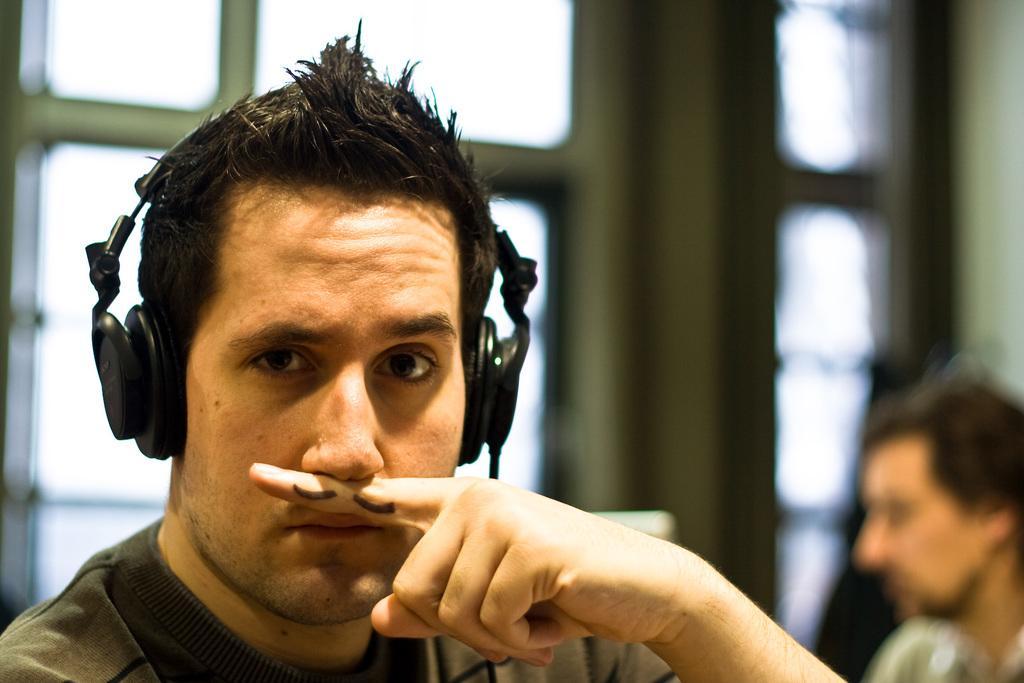In one or two sentences, can you explain what this image depicts? There is a man wore headset. In the background it is blurry and we can see person and window. 